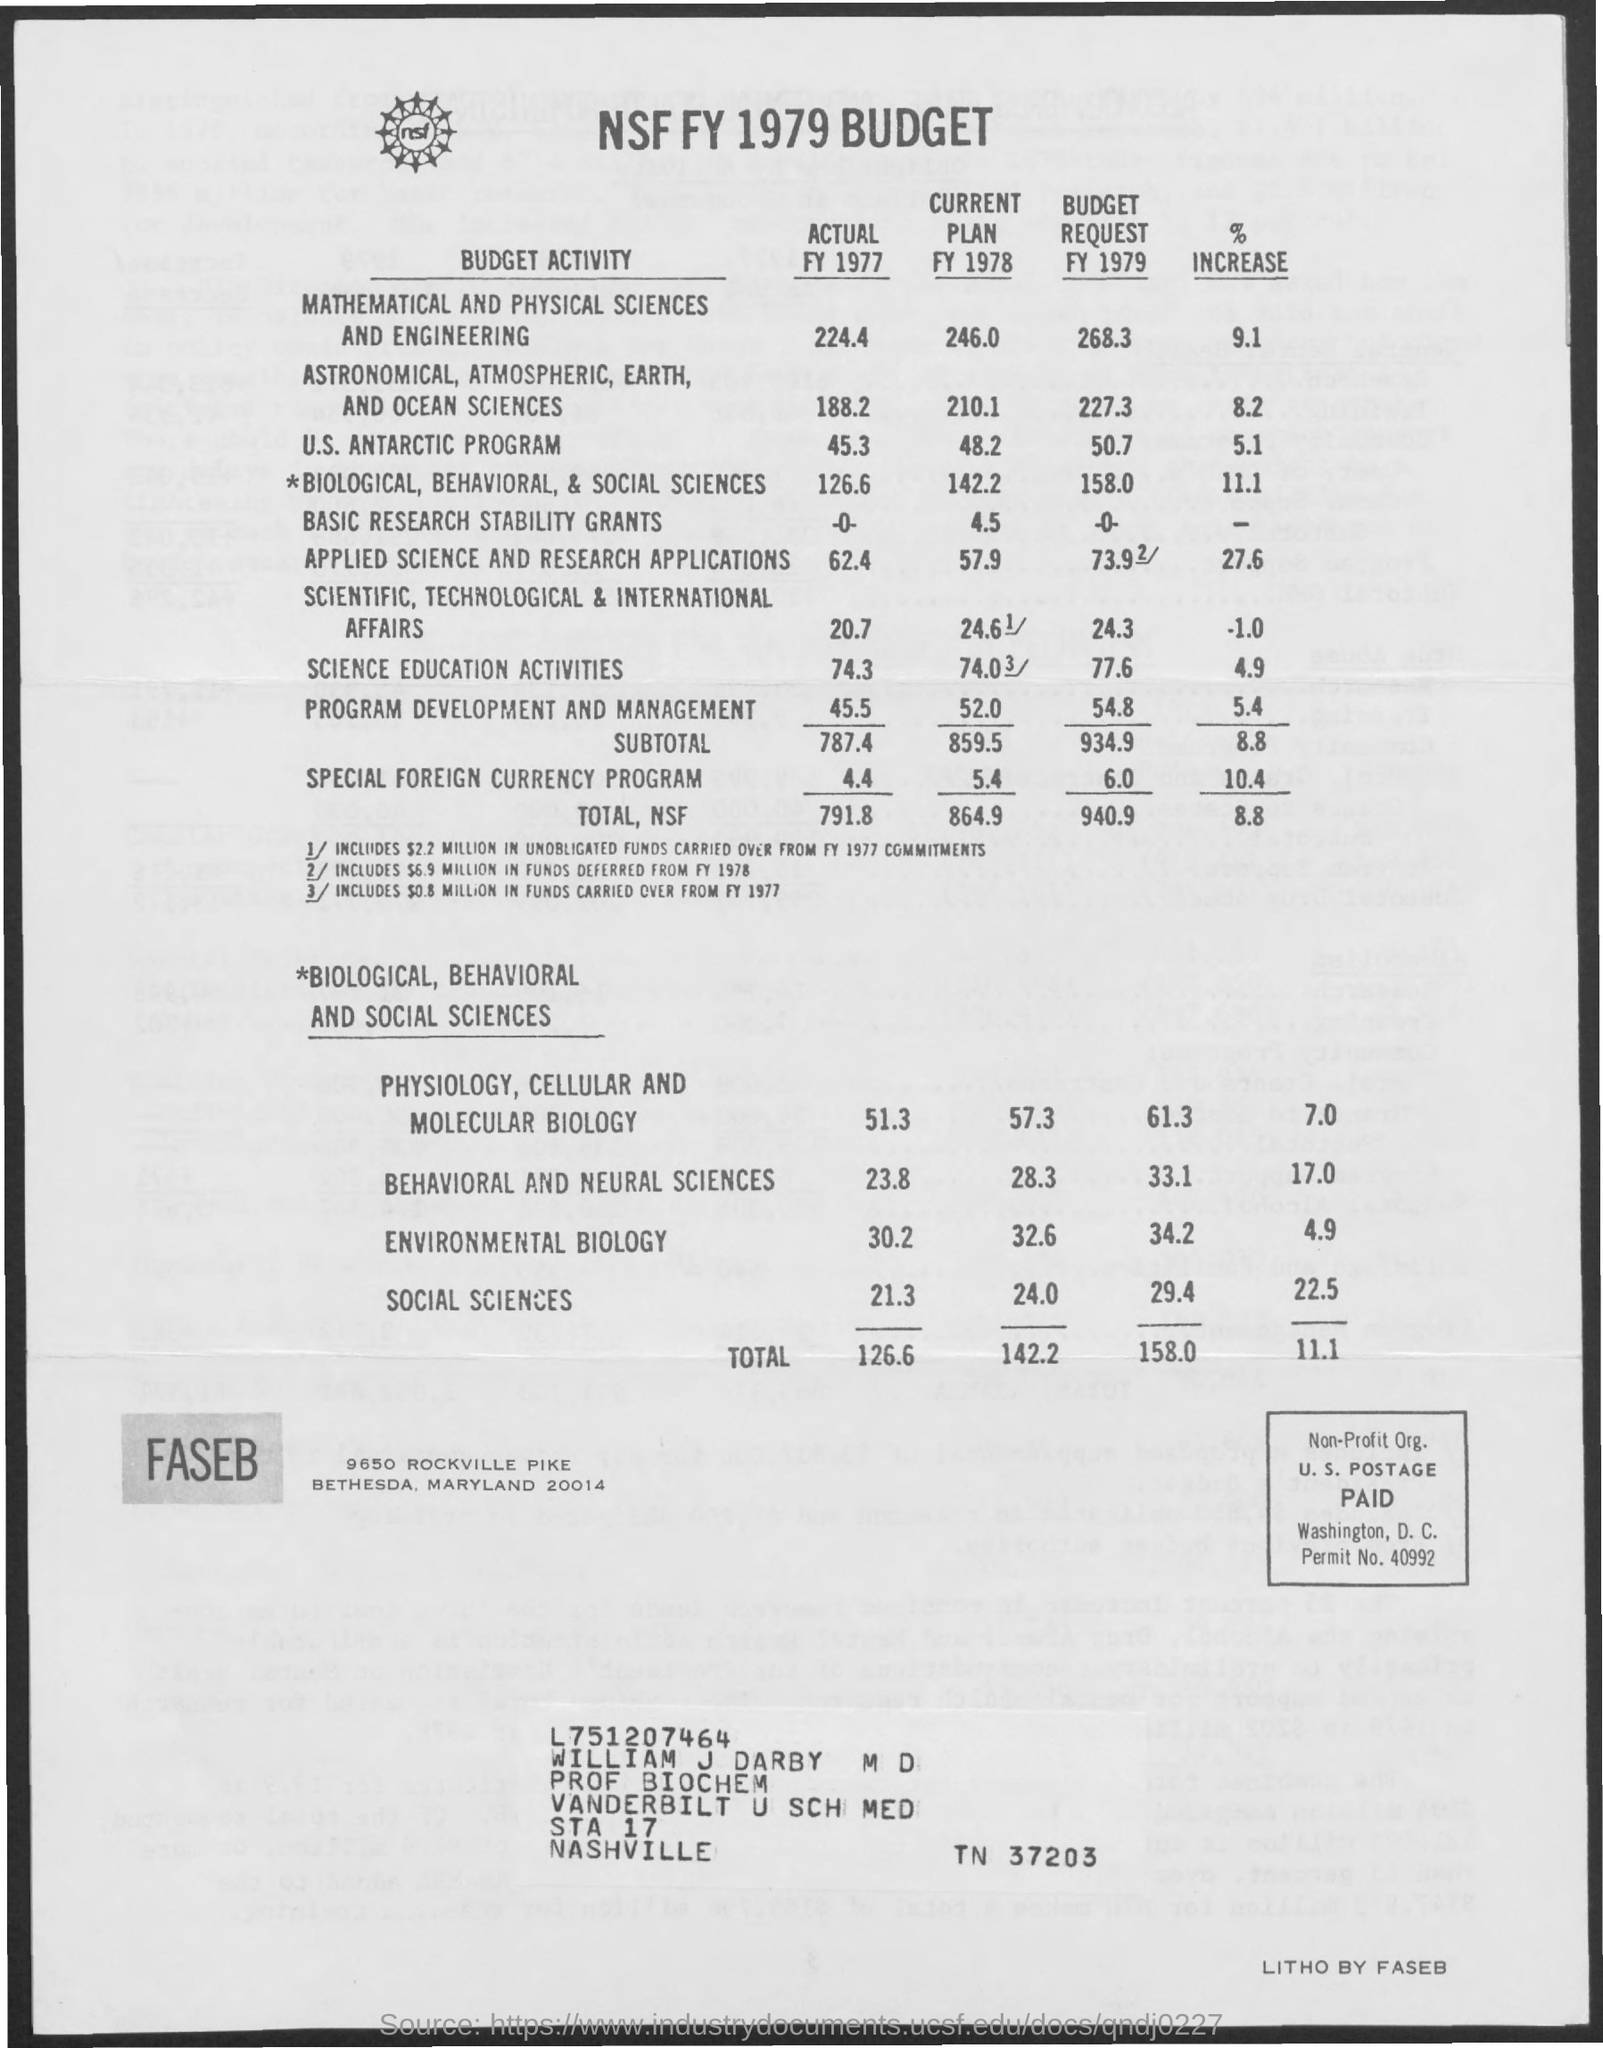Give some essential details in this illustration. The budget for the Special Foreign Currency program in Fiscal Year 1978 was 5.4. The total actual budget during Fiscal Year (FY) 1977 was $791.8 million. In the FY 1977 budget, the highest amount of funds was allocated to Mathematical and Physical sciences and engineering. The total budget request for fiscal year 1979 is 940.9. This budget refers to the year 1979. 